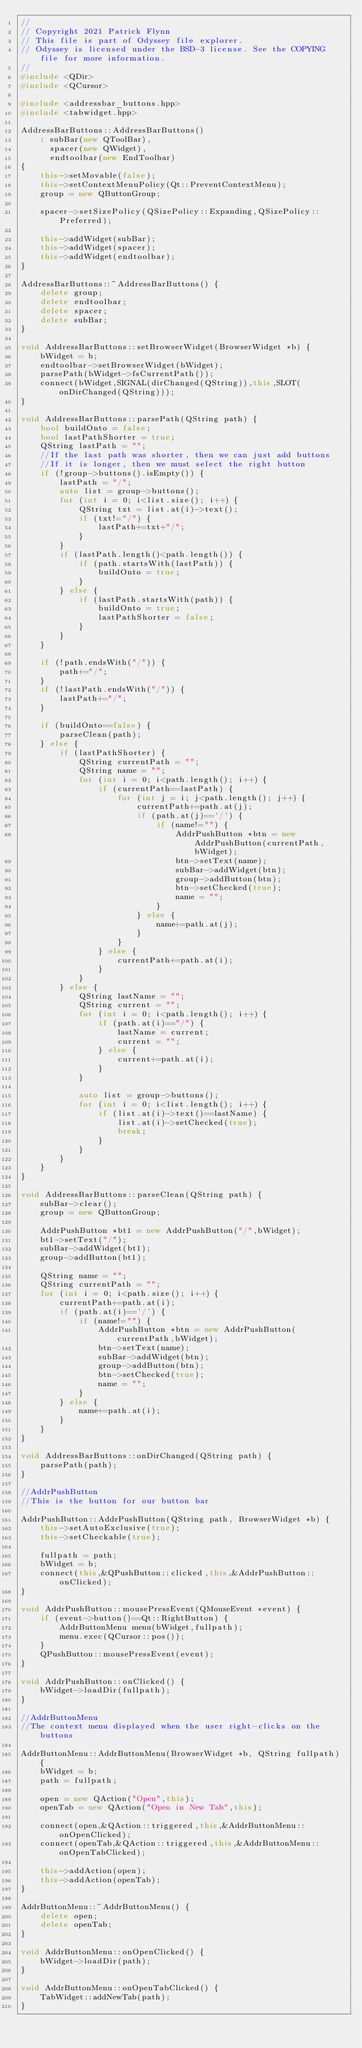Convert code to text. <code><loc_0><loc_0><loc_500><loc_500><_C++_>//
// Copyright 2021 Patrick Flynn
// This file is part of Odyssey file explorer.
// Odyssey is licensed under the BSD-3 license. See the COPYING file for more information.
//
#include <QDir>
#include <QCursor>

#include <addressbar_buttons.hpp>
#include <tabwidget.hpp>

AddressBarButtons::AddressBarButtons()
    : subBar(new QToolBar),
      spacer(new QWidget),
      endtoolbar(new EndToolbar)
{
    this->setMovable(false);
    this->setContextMenuPolicy(Qt::PreventContextMenu);
    group = new QButtonGroup;

    spacer->setSizePolicy(QSizePolicy::Expanding,QSizePolicy::Preferred);

    this->addWidget(subBar);
    this->addWidget(spacer);
    this->addWidget(endtoolbar);
}

AddressBarButtons::~AddressBarButtons() {
    delete group;
    delete endtoolbar;
    delete spacer;
    delete subBar;
}

void AddressBarButtons::setBrowserWidget(BrowserWidget *b) {
    bWidget = b;
    endtoolbar->setBrowserWidget(bWidget);
    parsePath(bWidget->fsCurrentPath());
    connect(bWidget,SIGNAL(dirChanged(QString)),this,SLOT(onDirChanged(QString)));
}

void AddressBarButtons::parsePath(QString path) {
    bool buildOnto = false;
    bool lastPathShorter = true;
    QString lastPath = "";
    //If the last path was shorter, then we can just add buttons
    //If it is longer, then we must select the right button
    if (!group->buttons().isEmpty()) {
        lastPath = "/";
        auto list = group->buttons();
        for (int i = 0; i<list.size(); i++) {
            QString txt = list.at(i)->text();
            if (txt!="/") {
                lastPath+=txt+"/";
            }
        }
        if (lastPath.length()<path.length()) {
            if (path.startsWith(lastPath)) {
                buildOnto = true;
            }
        } else {
            if (lastPath.startsWith(path)) {
                buildOnto = true;
                lastPathShorter = false;
            }
        }
    }

    if (!path.endsWith("/")) {
        path+="/";
    }
    if (!lastPath.endsWith("/")) {
        lastPath+="/";
    }

    if (buildOnto==false) {
        parseClean(path);
    } else {
        if (lastPathShorter) {
            QString currentPath = "";
            QString name = "";
            for (int i = 0; i<path.length(); i++) {
                if (currentPath==lastPath) {
                    for (int j = i; j<path.length(); j++) {
                        currentPath+=path.at(j);
                        if (path.at(j)=='/') {
                            if (name!="") {
                                AddrPushButton *btn = new AddrPushButton(currentPath,bWidget);
                                btn->setText(name);
                                subBar->addWidget(btn);
                                group->addButton(btn);
                                btn->setChecked(true);
                                name = "";
                            }
                        } else {
                            name+=path.at(j);
                        }
                    }
                } else {
                    currentPath+=path.at(i);
                }
            }
        } else {
            QString lastName = "";
            QString current = "";
            for (int i = 0; i<path.length(); i++) {
                if (path.at(i)=="/") {
                    lastName = current;
                    current = "";
                } else {
                    current+=path.at(i);
                }
            }

            auto list = group->buttons();
            for (int i = 0; i<list.length(); i++) {
                if (list.at(i)->text()==lastName) {
                    list.at(i)->setChecked(true);
                    break;
                }
            }
        }
    }
}

void AddressBarButtons::parseClean(QString path) {
    subBar->clear();
    group = new QButtonGroup;

    AddrPushButton *bt1 = new AddrPushButton("/",bWidget);
    bt1->setText("/");
    subBar->addWidget(bt1);
    group->addButton(bt1);

    QString name = "";
    QString currentPath = "";
    for (int i = 0; i<path.size(); i++) {
        currentPath+=path.at(i);
        if (path.at(i)=='/') {
            if (name!="") {
                AddrPushButton *btn = new AddrPushButton(currentPath,bWidget);
                btn->setText(name);
                subBar->addWidget(btn);
                group->addButton(btn);
                btn->setChecked(true);
                name = "";
            }
        } else {
            name+=path.at(i);
        }
    }
}

void AddressBarButtons::onDirChanged(QString path) {
    parsePath(path);
}

//AddrPushButton
//This is the button for our button bar

AddrPushButton::AddrPushButton(QString path, BrowserWidget *b) {
    this->setAutoExclusive(true);
    this->setCheckable(true);

    fullpath = path;
    bWidget = b;
    connect(this,&QPushButton::clicked,this,&AddrPushButton::onClicked);
}

void AddrPushButton::mousePressEvent(QMouseEvent *event) {
    if (event->button()==Qt::RightButton) {
        AddrButtonMenu menu(bWidget,fullpath);
        menu.exec(QCursor::pos());
    }
    QPushButton::mousePressEvent(event);
}

void AddrPushButton::onClicked() {
    bWidget->loadDir(fullpath);
}

//AddrButtonMenu
//The context menu displayed when the user right-clicks on the buttons

AddrButtonMenu::AddrButtonMenu(BrowserWidget *b, QString fullpath) {
    bWidget = b;
    path = fullpath;

    open = new QAction("Open",this);
    openTab = new QAction("Open in New Tab",this);

    connect(open,&QAction::triggered,this,&AddrButtonMenu::onOpenClicked);
    connect(openTab,&QAction::triggered,this,&AddrButtonMenu::onOpenTabClicked);

    this->addAction(open);
    this->addAction(openTab);
}

AddrButtonMenu::~AddrButtonMenu() {
    delete open;
    delete openTab;
}

void AddrButtonMenu::onOpenClicked() {
    bWidget->loadDir(path);
}

void AddrButtonMenu::onOpenTabClicked() {
    TabWidget::addNewTab(path);
}
</code> 